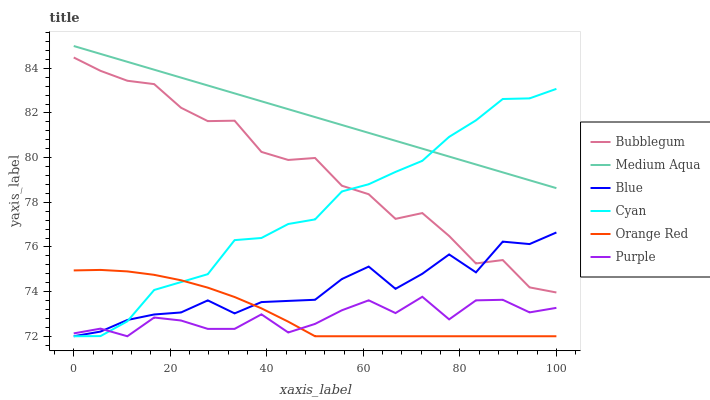Does Purple have the minimum area under the curve?
Answer yes or no. Yes. Does Medium Aqua have the maximum area under the curve?
Answer yes or no. Yes. Does Bubblegum have the minimum area under the curve?
Answer yes or no. No. Does Bubblegum have the maximum area under the curve?
Answer yes or no. No. Is Medium Aqua the smoothest?
Answer yes or no. Yes. Is Purple the roughest?
Answer yes or no. Yes. Is Bubblegum the smoothest?
Answer yes or no. No. Is Bubblegum the roughest?
Answer yes or no. No. Does Blue have the lowest value?
Answer yes or no. Yes. Does Bubblegum have the lowest value?
Answer yes or no. No. Does Medium Aqua have the highest value?
Answer yes or no. Yes. Does Bubblegum have the highest value?
Answer yes or no. No. Is Purple less than Medium Aqua?
Answer yes or no. Yes. Is Medium Aqua greater than Blue?
Answer yes or no. Yes. Does Purple intersect Blue?
Answer yes or no. Yes. Is Purple less than Blue?
Answer yes or no. No. Is Purple greater than Blue?
Answer yes or no. No. Does Purple intersect Medium Aqua?
Answer yes or no. No. 